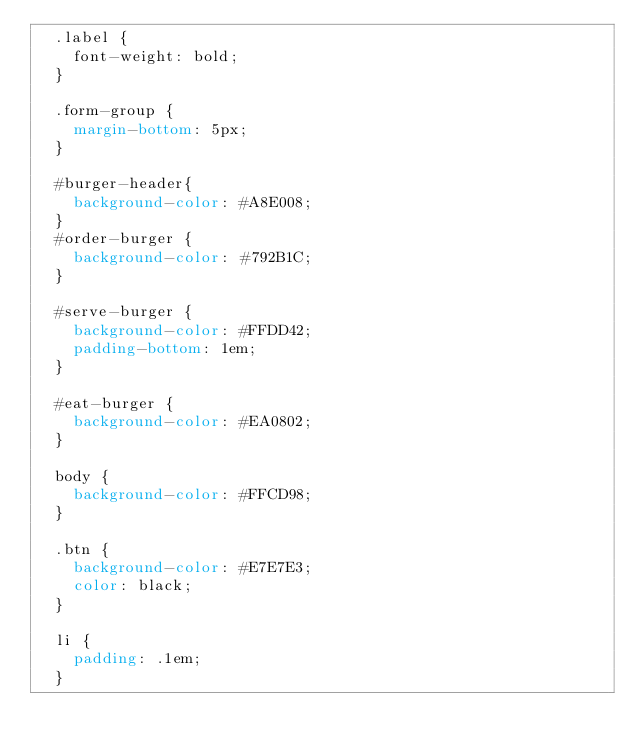<code> <loc_0><loc_0><loc_500><loc_500><_CSS_>  .label {
    font-weight: bold;
  }
  
  .form-group {
    margin-bottom: 5px;
  }

  #burger-header{
    background-color: #A8E008;
  }
  #order-burger {
    background-color: #792B1C;
  }

  #serve-burger {
    background-color: #FFDD42;
    padding-bottom: 1em;
  }

  #eat-burger {
    background-color: #EA0802;
  }

  body {
    background-color: #FFCD98;
  }

  .btn {
    background-color: #E7E7E3;
    color: black;
  }

  li {
    padding: .1em;
  }
</code> 